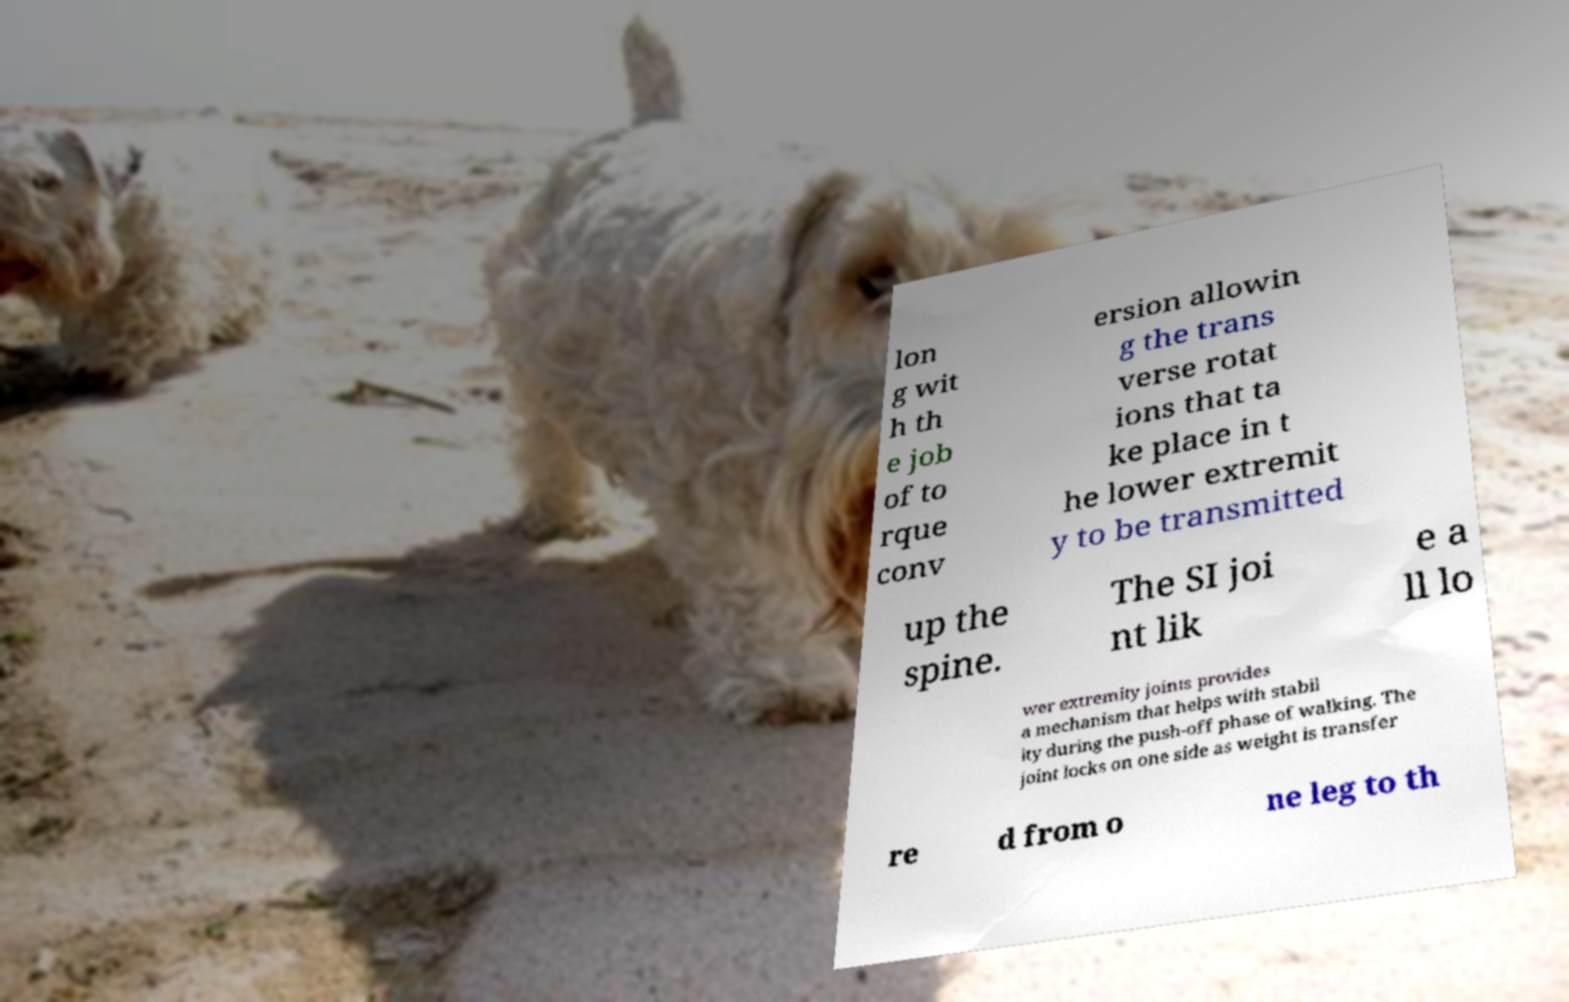Can you accurately transcribe the text from the provided image for me? lon g wit h th e job of to rque conv ersion allowin g the trans verse rotat ions that ta ke place in t he lower extremit y to be transmitted up the spine. The SI joi nt lik e a ll lo wer extremity joints provides a mechanism that helps with stabil ity during the push-off phase of walking. The joint locks on one side as weight is transfer re d from o ne leg to th 